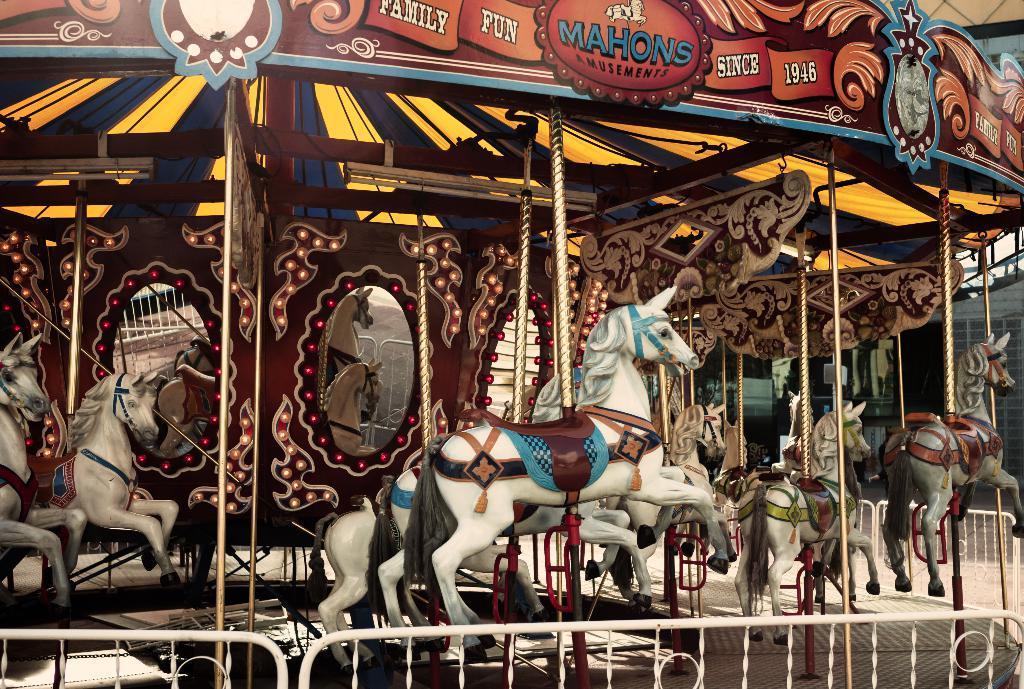Can you describe this image briefly? In this image I can see few toy horses and mirrors. In front I can see a white color fencing. It is a colorful ride. 